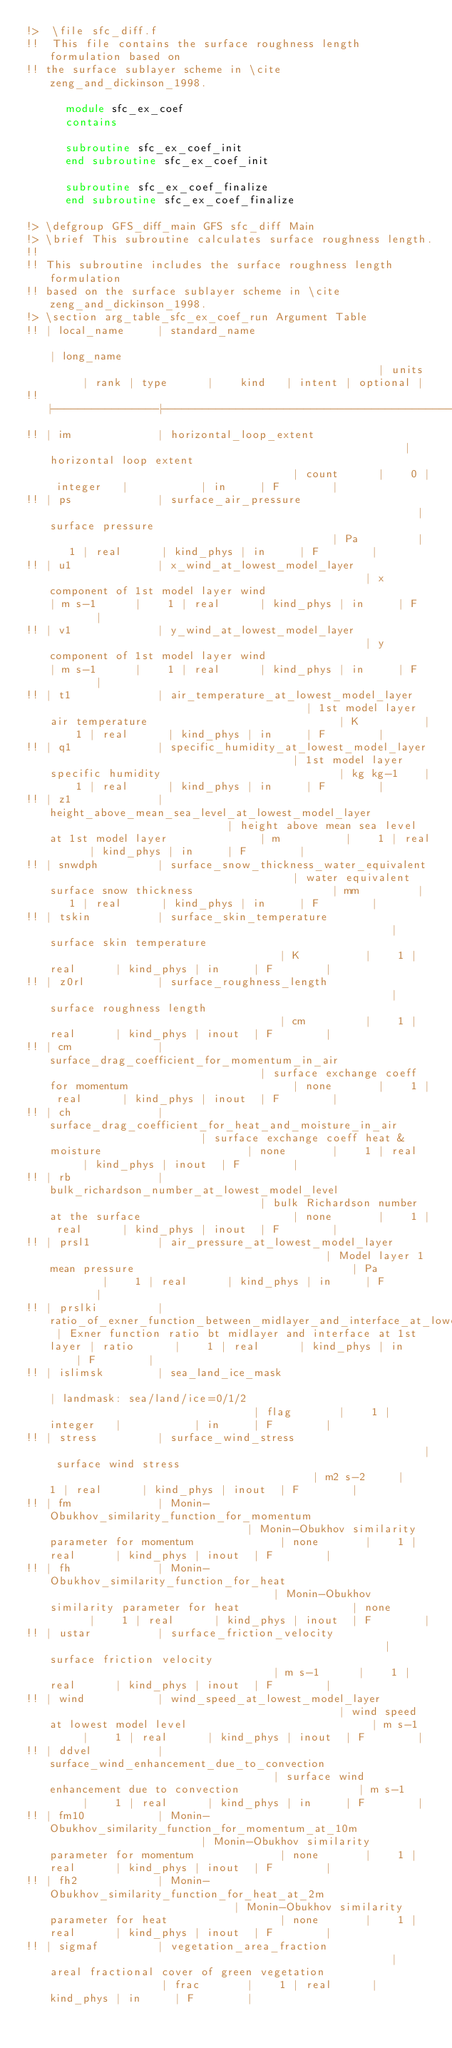<code> <loc_0><loc_0><loc_500><loc_500><_FORTRAN_>!>  \file sfc_diff.f
!!  This file contains the surface roughness length formulation based on 
!! the surface sublayer scheme in \cite zeng_and_dickinson_1998. 

      module sfc_ex_coef
      contains

      subroutine sfc_ex_coef_init
      end subroutine sfc_ex_coef_init

      subroutine sfc_ex_coef_finalize
      end subroutine sfc_ex_coef_finalize

!> \defgroup GFS_diff_main GFS sfc_diff Main
!> \brief This subroutine calculates surface roughness length.
!!
!! This subroutine includes the surface roughness length formulation
!! based on the surface sublayer scheme in \cite zeng_and_dickinson_1998.
!> \section arg_table_sfc_ex_coef_run Argument Table
!! | local_name     | standard_name                                                                | long_name                                                   | units      | rank | type      |    kind   | intent | optional |
!! |----------------|------------------------------------------------------------------------------|-------------------------------------------------------------|------------|------|-----------|-----------|--------|----------|
!! | im             | horizontal_loop_extent                                                       | horizontal loop extent                                      | count      |    0 | integer   |           | in     | F        |
!! | ps             | surface_air_pressure                                                         | surface pressure                                            | Pa         |    1 | real      | kind_phys | in     | F        |
!! | u1             | x_wind_at_lowest_model_layer                                                 | x component of 1st model layer wind                         | m s-1      |    1 | real      | kind_phys | in     | F        |
!! | v1             | y_wind_at_lowest_model_layer                                                 | y component of 1st model layer wind                         | m s-1      |    1 | real      | kind_phys | in     | F        |
!! | t1             | air_temperature_at_lowest_model_layer                                        | 1st model layer air temperature                             | K          |    1 | real      | kind_phys | in     | F        |
!! | q1             | specific_humidity_at_lowest_model_layer                                      | 1st model layer specific humidity                           | kg kg-1    |    1 | real      | kind_phys | in     | F        |
!! | z1             | height_above_mean_sea_level_at_lowest_model_layer                            | height above mean sea level at 1st model layer              | m          |    1 | real      | kind_phys | in     | F        |
!! | snwdph         | surface_snow_thickness_water_equivalent                                      | water equivalent surface snow thickness                     | mm         |    1 | real      | kind_phys | in     | F        |
!! | tskin          | surface_skin_temperature                                                     | surface skin temperature                                    | K          |    1 | real      | kind_phys | in     | F        |
!! | z0rl           | surface_roughness_length                                                     | surface roughness length                                    | cm         |    1 | real      | kind_phys | inout  | F        |
!! | cm             | surface_drag_coefficient_for_momentum_in_air                                 | surface exchange coeff for momentum                         | none       |    1 | real      | kind_phys | inout  | F        |
!! | ch             | surface_drag_coefficient_for_heat_and_moisture_in_air                        | surface exchange coeff heat & moisture                      | none       |    1 | real      | kind_phys | inout  | F        |
!! | rb             | bulk_richardson_number_at_lowest_model_level                                 | bulk Richardson number at the surface                       | none       |    1 | real      | kind_phys | inout  | F        |
!! | prsl1          | air_pressure_at_lowest_model_layer                                           | Model layer 1 mean pressure                                 | Pa         |    1 | real      | kind_phys | in     | F        |
!! | prslki         | ratio_of_exner_function_between_midlayer_and_interface_at_lowest_model_layer | Exner function ratio bt midlayer and interface at 1st layer | ratio      |    1 | real      | kind_phys | in     | F        |
!! | islimsk        | sea_land_ice_mask                                                            | landmask: sea/land/ice=0/1/2                                | flag       |    1 | integer   |           | in     | F        |
!! | stress         | surface_wind_stress                                                          | surface wind stress                                         | m2 s-2     |    1 | real      | kind_phys | inout  | F        |
!! | fm             | Monin-Obukhov_similarity_function_for_momentum                               | Monin-Obukhov similarity parameter for momentum             | none       |    1 | real      | kind_phys | inout  | F        |
!! | fh             | Monin-Obukhov_similarity_function_for_heat                                   | Monin-Obukhov similarity parameter for heat                 | none       |    1 | real      | kind_phys | inout  | F        |
!! | ustar          | surface_friction_velocity                                                    | surface friction velocity                                   | m s-1      |    1 | real      | kind_phys | inout  | F        |
!! | wind           | wind_speed_at_lowest_model_layer                                             | wind speed at lowest model level                            | m s-1      |    1 | real      | kind_phys | inout  | F        |
!! | ddvel          | surface_wind_enhancement_due_to_convection                                   | surface wind enhancement due to convection                  | m s-1      |    1 | real      | kind_phys | in     | F        |
!! | fm10           | Monin-Obukhov_similarity_function_for_momentum_at_10m                        | Monin-Obukhov similarity parameter for momentum             | none       |    1 | real      | kind_phys | inout  | F        |
!! | fh2            | Monin-Obukhov_similarity_function_for_heat_at_2m                             | Monin-Obukhov similarity parameter for heat                 | none       |    1 | real      | kind_phys | inout  | F        |
!! | sigmaf         | vegetation_area_fraction                                                     | areal fractional cover of green vegetation                  | frac       |    1 | real      | kind_phys | in     | F        |</code> 